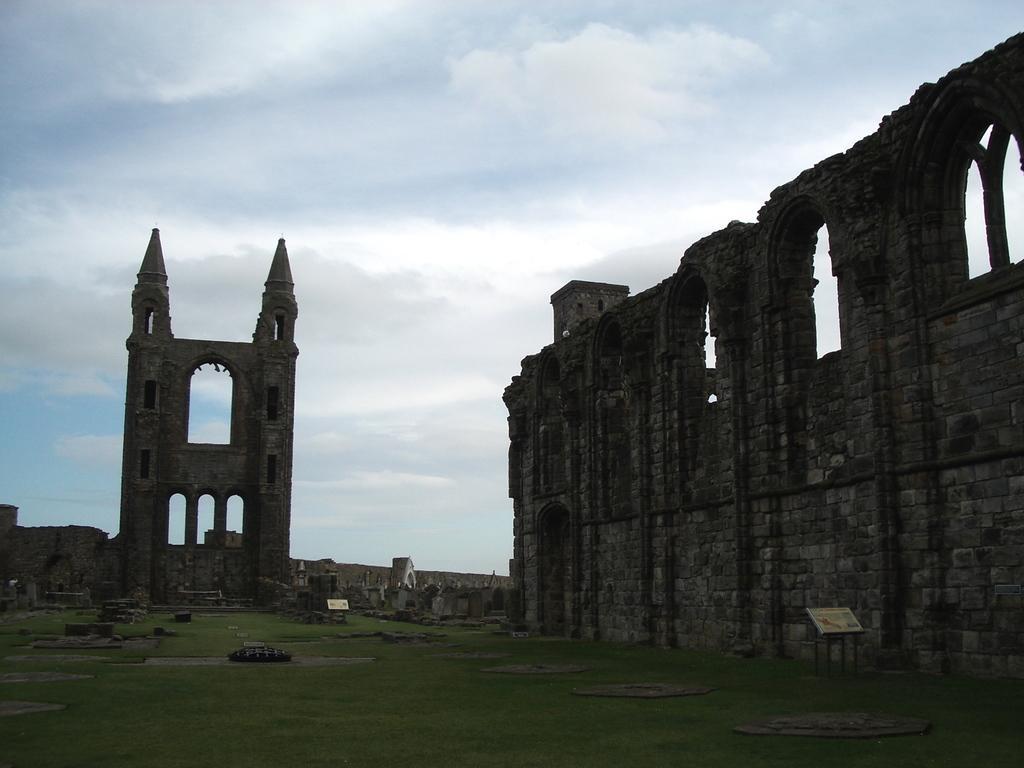In one or two sentences, can you explain what this image depicts? In this picture I can observe a monument. There is some grass on the ground. In the background there are some clouds in the sky. 